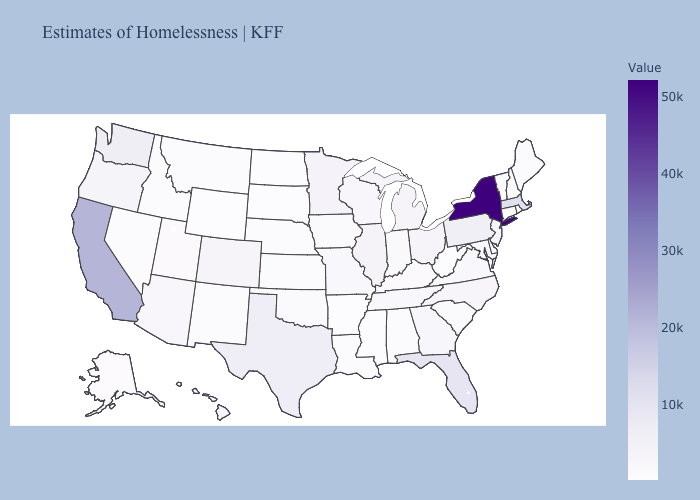Which states hav the highest value in the MidWest?
Be succinct. Illinois. Which states have the lowest value in the South?
Give a very brief answer. West Virginia. Which states have the lowest value in the USA?
Quick response, please. Wyoming. Which states have the lowest value in the West?
Write a very short answer. Wyoming. 